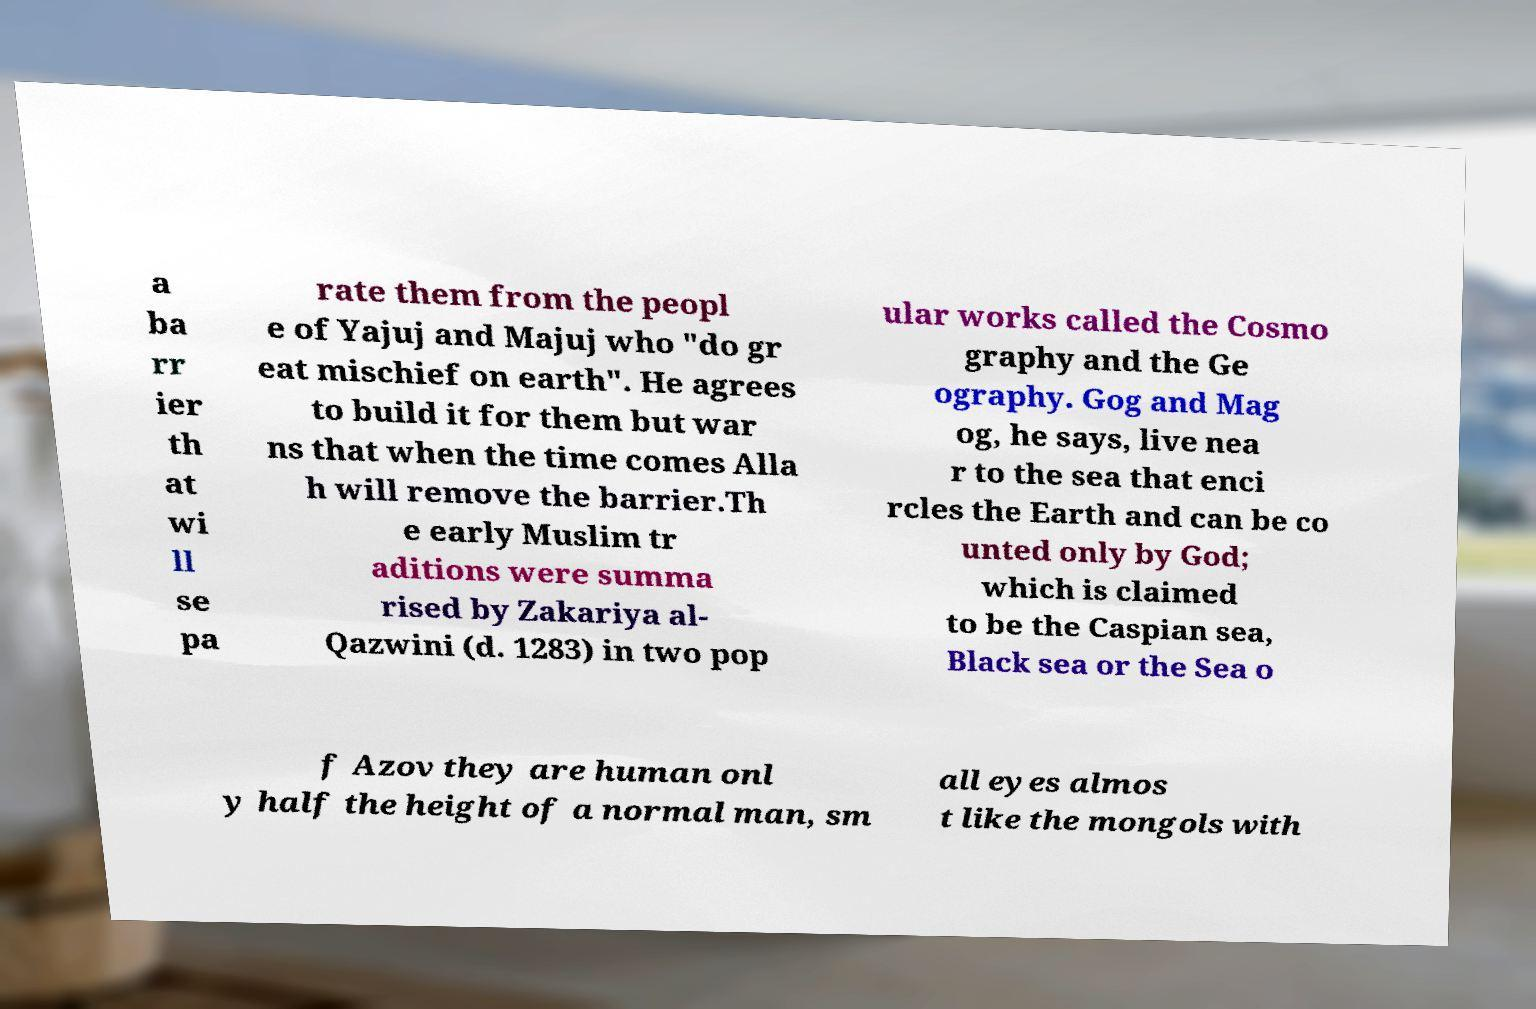What messages or text are displayed in this image? I need them in a readable, typed format. a ba rr ier th at wi ll se pa rate them from the peopl e of Yajuj and Majuj who "do gr eat mischief on earth". He agrees to build it for them but war ns that when the time comes Alla h will remove the barrier.Th e early Muslim tr aditions were summa rised by Zakariya al- Qazwini (d. 1283) in two pop ular works called the Cosmo graphy and the Ge ography. Gog and Mag og, he says, live nea r to the sea that enci rcles the Earth and can be co unted only by God; which is claimed to be the Caspian sea, Black sea or the Sea o f Azov they are human onl y half the height of a normal man, sm all eyes almos t like the mongols with 